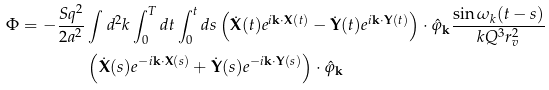Convert formula to latex. <formula><loc_0><loc_0><loc_500><loc_500>\Phi = - \frac { S q ^ { 2 } } { 2 a ^ { 2 } } & \int d ^ { 2 } k \int _ { 0 } ^ { T } d t \int _ { 0 } ^ { t } d s \left ( \dot { \mathbf X } ( t ) e ^ { i \mathbf k \cdot \mathbf X ( t ) } - \dot { \mathbf Y } ( t ) e ^ { i \mathbf k \cdot \mathbf Y ( t ) } \right ) \cdot \hat { \varphi } _ { \mathbf k } \frac { \sin \omega _ { k } ( t - s ) } { k Q ^ { 3 } r _ { v } ^ { 2 } } \\ & \left ( \dot { \mathbf X } ( s ) e ^ { - i \mathbf k \cdot \mathbf X ( s ) } + \dot { \mathbf Y } ( s ) e ^ { - i \mathbf k \cdot \mathbf Y ( s ) } \right ) \cdot \hat { \varphi } _ { \mathbf k }</formula> 